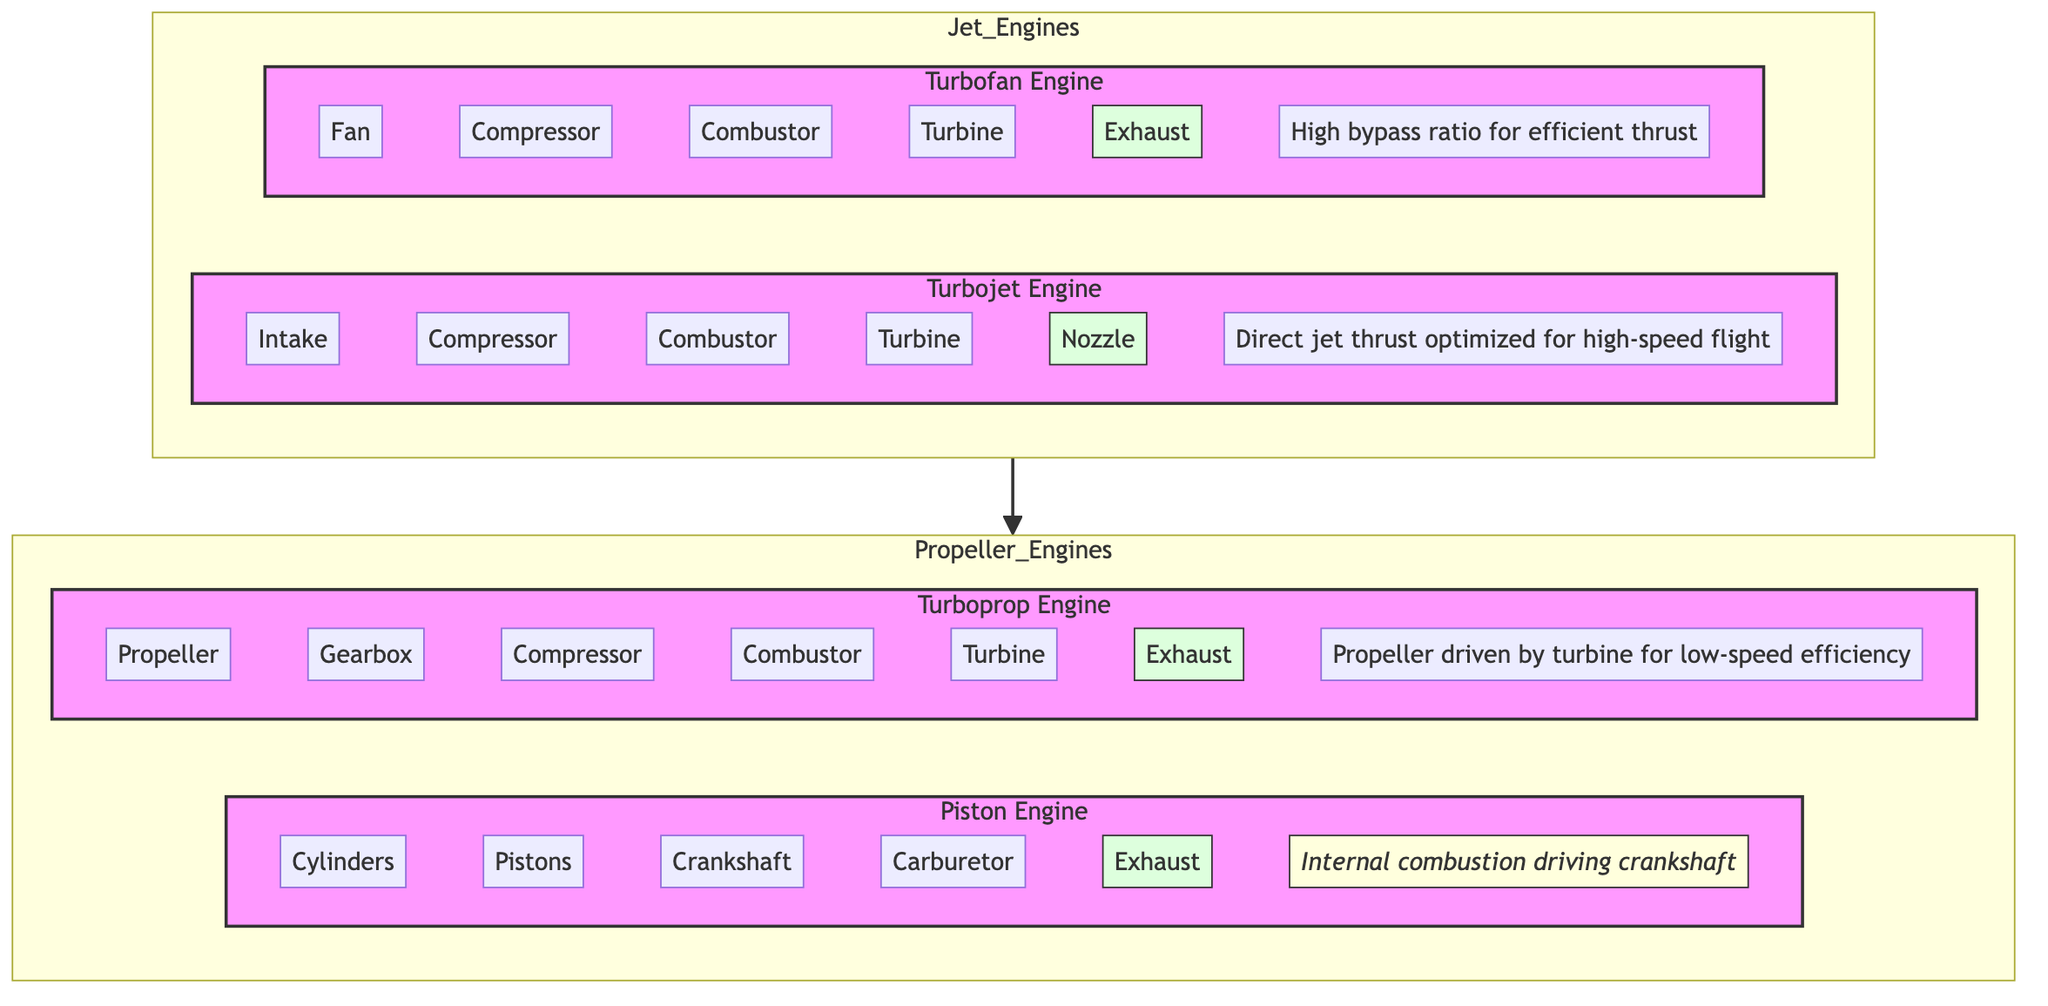What are the main components of a turbofan engine? In the diagram, the turbofan engine includes five main components: Fan, Compressor, Combustor, Turbine, and Exhaust. These components are visually represented within the Turbofan subgraph.
Answer: Fan, Compressor, Combustor, Turbine, Exhaust How many engines are classified as jet engines in the diagram? The diagram shows two types of jet engines: Turbofan and Turbojet, represented within the Jet_Engines subgraph.
Answer: 2 What is the principle of operation for a turbojet engine? The principle listed for the turbojet engine explains that it operates using "Direct jet thrust optimized for high-speed flight." It is shown within the Turbojet subgraph in the diagram.
Answer: Direct jet thrust optimized for high-speed flight Identify the relationship between turboprop and turbojet engines. Looking at the diagram structure, both turboprop and turbojet engines are part of a larger category of engines. They both fall under the subgraph categories of Propeller_Engines and Jet_Engines respectively, indicating a classification hierarchy.
Answer: Both categorized under engine types Which engine type has a principle focused on low-speed efficiency? The turboprop engine is noted to operate with the principle "Propeller driven by turbine for low-speed efficiency," indicated within the Turboprop subgraph.
Answer: Turboprop engine How many components are present in a piston engine? The piston engine has five components listed: Cylinders, Pistons, Crankshaft, Carburetor, and Exhaust. These can be counted within the Piston subgraph of the diagram.
Answer: 5 What component is unique to turboprop engines compared to other types? The component unique to the turboprop engine, which is not found in jet engines, is the Propeller. It can be seen listed in the Turboprop subgraph's components.
Answer: Propeller What is the main difference in the principle of operation between turbofan and turbojet engines? Comparing their principles, the turbofan focuses on "High bypass ratio for efficient thrust," while the turbojet emphasizes "Direct jet thrust optimized for high-speed flight," indicating a different operational focus.
Answer: High bypass ratio vs. Direct jet thrust What type of engine utilizes internal combustion to drive its components? The piston engine is noted for its principle of "Internal combustion driving crankshaft," making it the only type mentioned with an internal combustion process.
Answer: Piston engine 